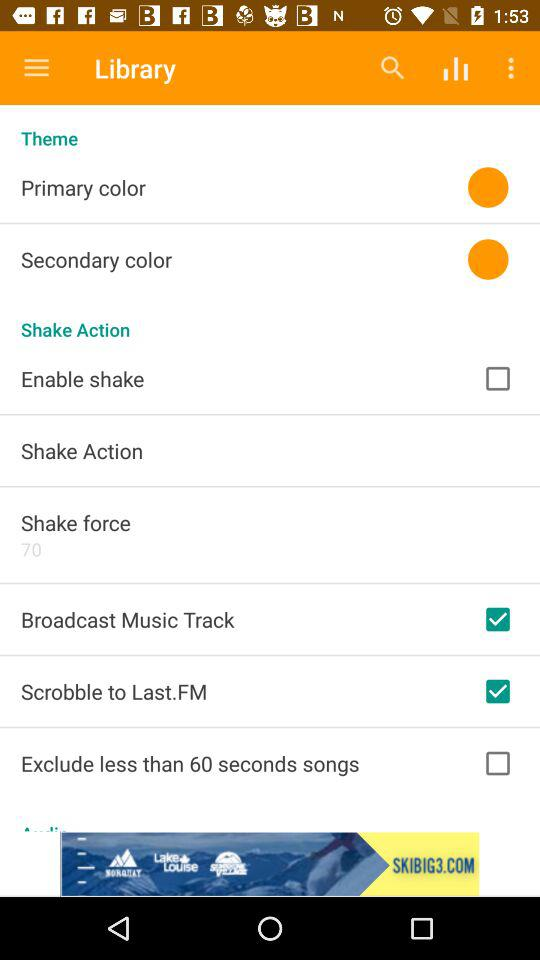What is the checked option? The checked options are "Broadcast Music Track" and "Scrobble to Last.FM". 